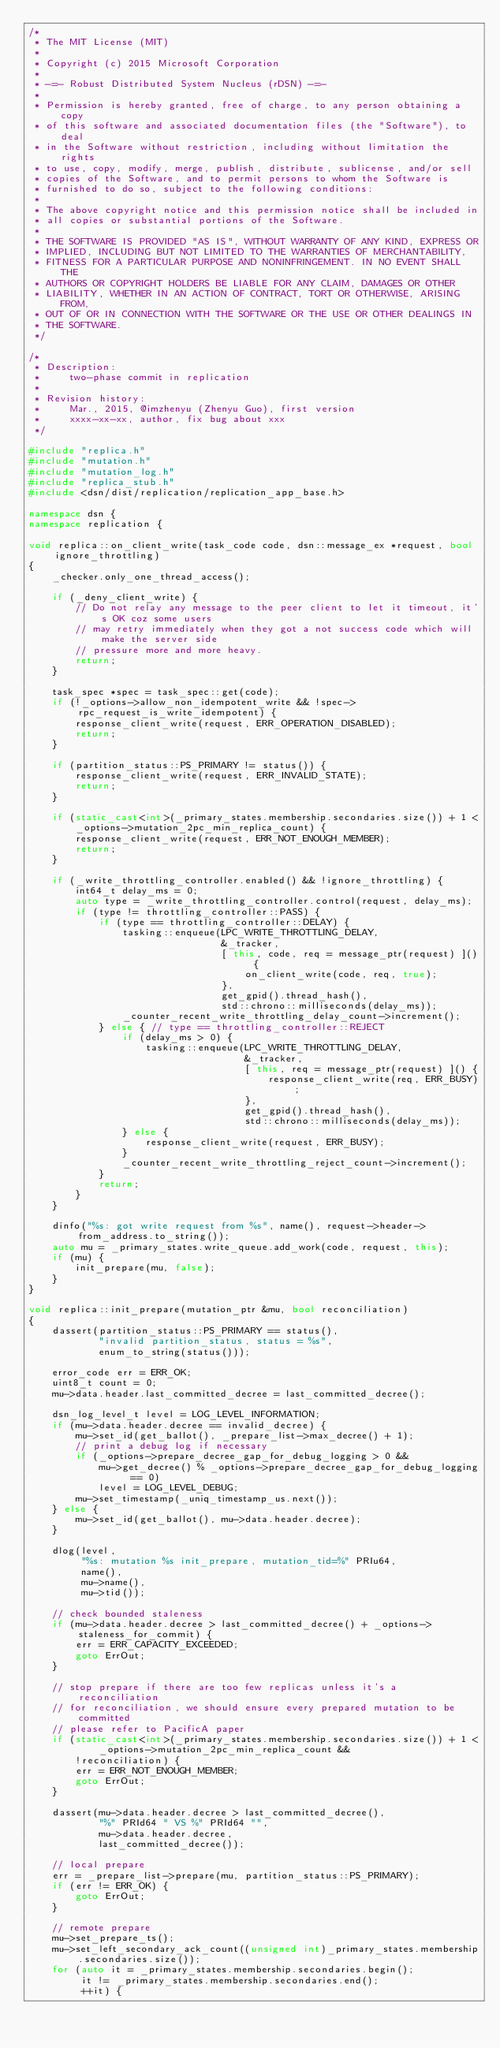Convert code to text. <code><loc_0><loc_0><loc_500><loc_500><_C++_>/*
 * The MIT License (MIT)
 *
 * Copyright (c) 2015 Microsoft Corporation
 *
 * -=- Robust Distributed System Nucleus (rDSN) -=-
 *
 * Permission is hereby granted, free of charge, to any person obtaining a copy
 * of this software and associated documentation files (the "Software"), to deal
 * in the Software without restriction, including without limitation the rights
 * to use, copy, modify, merge, publish, distribute, sublicense, and/or sell
 * copies of the Software, and to permit persons to whom the Software is
 * furnished to do so, subject to the following conditions:
 *
 * The above copyright notice and this permission notice shall be included in
 * all copies or substantial portions of the Software.
 *
 * THE SOFTWARE IS PROVIDED "AS IS", WITHOUT WARRANTY OF ANY KIND, EXPRESS OR
 * IMPLIED, INCLUDING BUT NOT LIMITED TO THE WARRANTIES OF MERCHANTABILITY,
 * FITNESS FOR A PARTICULAR PURPOSE AND NONINFRINGEMENT. IN NO EVENT SHALL THE
 * AUTHORS OR COPYRIGHT HOLDERS BE LIABLE FOR ANY CLAIM, DAMAGES OR OTHER
 * LIABILITY, WHETHER IN AN ACTION OF CONTRACT, TORT OR OTHERWISE, ARISING FROM,
 * OUT OF OR IN CONNECTION WITH THE SOFTWARE OR THE USE OR OTHER DEALINGS IN
 * THE SOFTWARE.
 */

/*
 * Description:
 *     two-phase commit in replication
 *
 * Revision history:
 *     Mar., 2015, @imzhenyu (Zhenyu Guo), first version
 *     xxxx-xx-xx, author, fix bug about xxx
 */

#include "replica.h"
#include "mutation.h"
#include "mutation_log.h"
#include "replica_stub.h"
#include <dsn/dist/replication/replication_app_base.h>

namespace dsn {
namespace replication {

void replica::on_client_write(task_code code, dsn::message_ex *request, bool ignore_throttling)
{
    _checker.only_one_thread_access();

    if (_deny_client_write) {
        // Do not relay any message to the peer client to let it timeout, it's OK coz some users
        // may retry immediately when they got a not success code which will make the server side
        // pressure more and more heavy.
        return;
    }

    task_spec *spec = task_spec::get(code);
    if (!_options->allow_non_idempotent_write && !spec->rpc_request_is_write_idempotent) {
        response_client_write(request, ERR_OPERATION_DISABLED);
        return;
    }

    if (partition_status::PS_PRIMARY != status()) {
        response_client_write(request, ERR_INVALID_STATE);
        return;
    }

    if (static_cast<int>(_primary_states.membership.secondaries.size()) + 1 <
        _options->mutation_2pc_min_replica_count) {
        response_client_write(request, ERR_NOT_ENOUGH_MEMBER);
        return;
    }

    if (_write_throttling_controller.enabled() && !ignore_throttling) {
        int64_t delay_ms = 0;
        auto type = _write_throttling_controller.control(request, delay_ms);
        if (type != throttling_controller::PASS) {
            if (type == throttling_controller::DELAY) {
                tasking::enqueue(LPC_WRITE_THROTTLING_DELAY,
                                 &_tracker,
                                 [ this, code, req = message_ptr(request) ]() {
                                     on_client_write(code, req, true);
                                 },
                                 get_gpid().thread_hash(),
                                 std::chrono::milliseconds(delay_ms));
                _counter_recent_write_throttling_delay_count->increment();
            } else { // type == throttling_controller::REJECT
                if (delay_ms > 0) {
                    tasking::enqueue(LPC_WRITE_THROTTLING_DELAY,
                                     &_tracker,
                                     [ this, req = message_ptr(request) ]() {
                                         response_client_write(req, ERR_BUSY);
                                     },
                                     get_gpid().thread_hash(),
                                     std::chrono::milliseconds(delay_ms));
                } else {
                    response_client_write(request, ERR_BUSY);
                }
                _counter_recent_write_throttling_reject_count->increment();
            }
            return;
        }
    }

    dinfo("%s: got write request from %s", name(), request->header->from_address.to_string());
    auto mu = _primary_states.write_queue.add_work(code, request, this);
    if (mu) {
        init_prepare(mu, false);
    }
}

void replica::init_prepare(mutation_ptr &mu, bool reconciliation)
{
    dassert(partition_status::PS_PRIMARY == status(),
            "invalid partition_status, status = %s",
            enum_to_string(status()));

    error_code err = ERR_OK;
    uint8_t count = 0;
    mu->data.header.last_committed_decree = last_committed_decree();

    dsn_log_level_t level = LOG_LEVEL_INFORMATION;
    if (mu->data.header.decree == invalid_decree) {
        mu->set_id(get_ballot(), _prepare_list->max_decree() + 1);
        // print a debug log if necessary
        if (_options->prepare_decree_gap_for_debug_logging > 0 &&
            mu->get_decree() % _options->prepare_decree_gap_for_debug_logging == 0)
            level = LOG_LEVEL_DEBUG;
        mu->set_timestamp(_uniq_timestamp_us.next());
    } else {
        mu->set_id(get_ballot(), mu->data.header.decree);
    }

    dlog(level,
         "%s: mutation %s init_prepare, mutation_tid=%" PRIu64,
         name(),
         mu->name(),
         mu->tid());

    // check bounded staleness
    if (mu->data.header.decree > last_committed_decree() + _options->staleness_for_commit) {
        err = ERR_CAPACITY_EXCEEDED;
        goto ErrOut;
    }

    // stop prepare if there are too few replicas unless it's a reconciliation
    // for reconciliation, we should ensure every prepared mutation to be committed
    // please refer to PacificA paper
    if (static_cast<int>(_primary_states.membership.secondaries.size()) + 1 <
            _options->mutation_2pc_min_replica_count &&
        !reconciliation) {
        err = ERR_NOT_ENOUGH_MEMBER;
        goto ErrOut;
    }

    dassert(mu->data.header.decree > last_committed_decree(),
            "%" PRId64 " VS %" PRId64 "",
            mu->data.header.decree,
            last_committed_decree());

    // local prepare
    err = _prepare_list->prepare(mu, partition_status::PS_PRIMARY);
    if (err != ERR_OK) {
        goto ErrOut;
    }

    // remote prepare
    mu->set_prepare_ts();
    mu->set_left_secondary_ack_count((unsigned int)_primary_states.membership.secondaries.size());
    for (auto it = _primary_states.membership.secondaries.begin();
         it != _primary_states.membership.secondaries.end();
         ++it) {</code> 